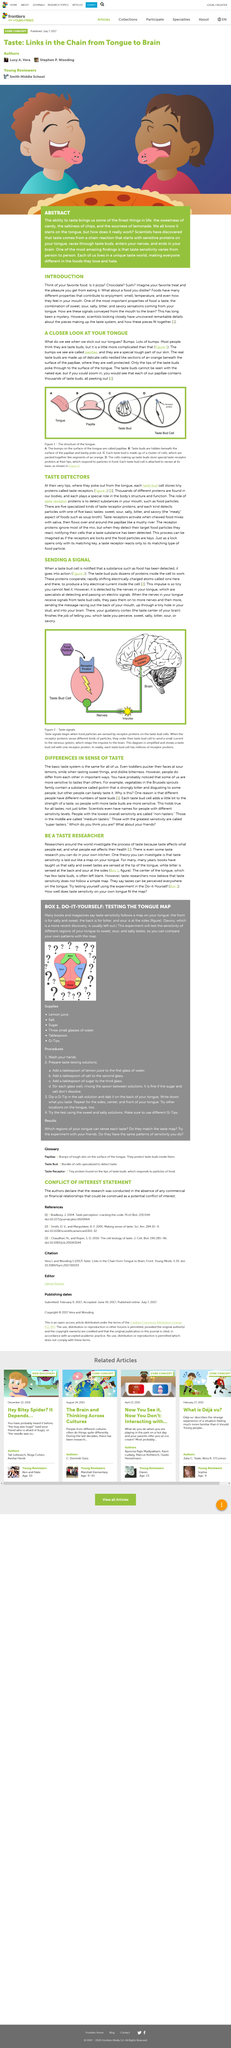List a handful of essential elements in this visual. It is possible to become a taste researcher by conducting a do-it-yourself experiment to test one's taste sensitivity on the tongue. Tastes can be perceived everywhere on the tongue, according to researchers. In particular, it is possible to taste both salt and sweet at the same time on the tongue. The picture shows food that is pizza. The taste sensitivity on the tongue is believed to be laid out like a map, according to researchers. Scientists have uncovered new details about the pieces that make up the taste system. 